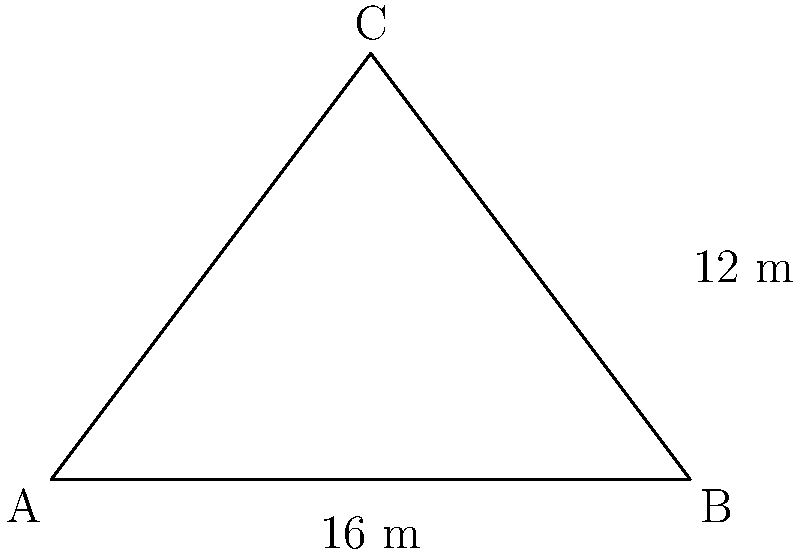In Camp Nou, the triangular penalty area of FC Barcelona's pitch has a base of 16 meters and a height of 12 meters. If Lionel Messi were to cover this entire area during a match, what would be the total surface area he'd need to defend? To find the area of the triangular penalty box, we can use the formula for the area of a triangle:

$$A = \frac{1}{2} \times b \times h$$

Where:
$A$ = Area of the triangle
$b$ = Base of the triangle
$h$ = Height of the triangle

Given:
Base (b) = 16 meters
Height (h) = 12 meters

Let's substitute these values into the formula:

$$A = \frac{1}{2} \times 16 \times 12$$

Now, let's calculate:

$$A = \frac{1}{2} \times 192$$
$$A = 96$$

Therefore, the area of the triangular penalty box is 96 square meters.
Answer: 96 m² 